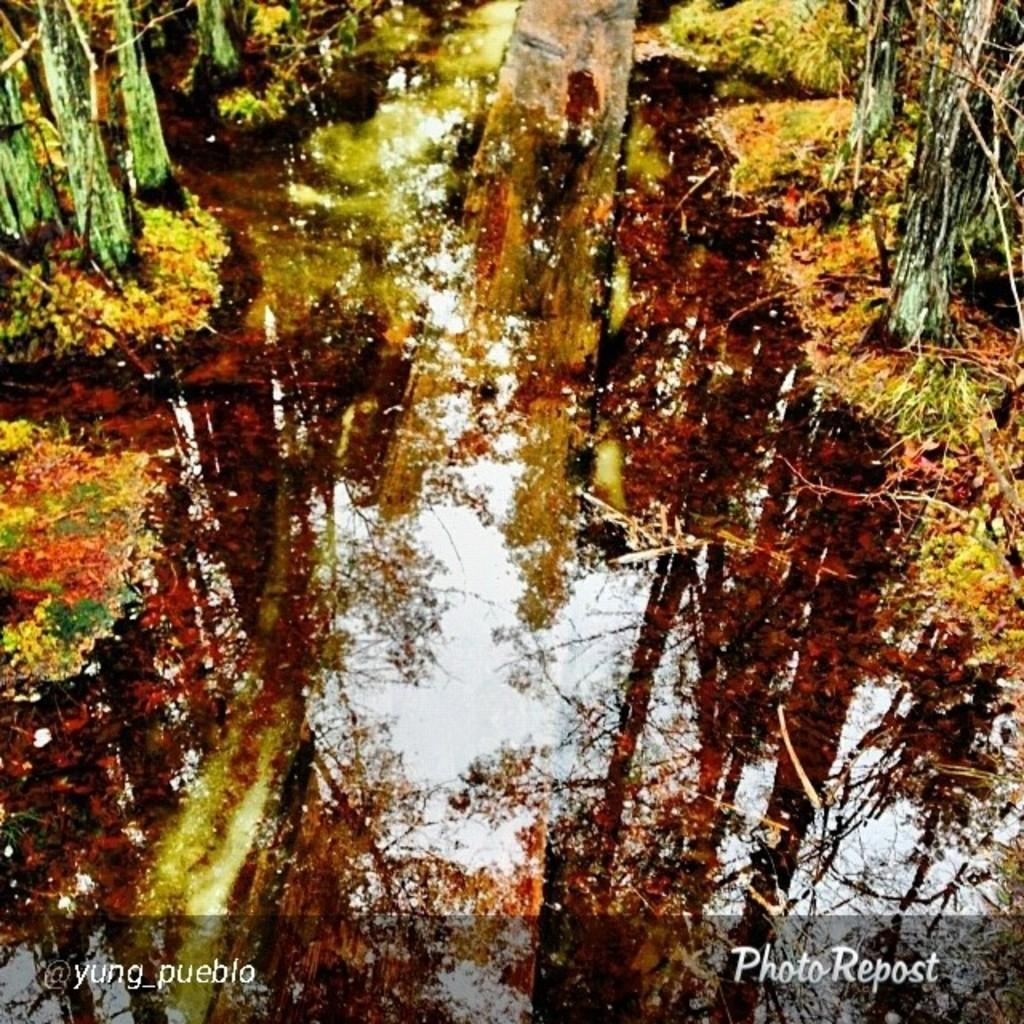What is present in the image that is not solid? There is water visible in the image. What can be seen near the water in the image? There are objects beside the water. What colors are the objects near the water? The objects are red and yellow in color. How many passengers are visible in the image? There are no passengers present in the image. What type of town can be seen in the background of the image? There is no town visible in the image. 